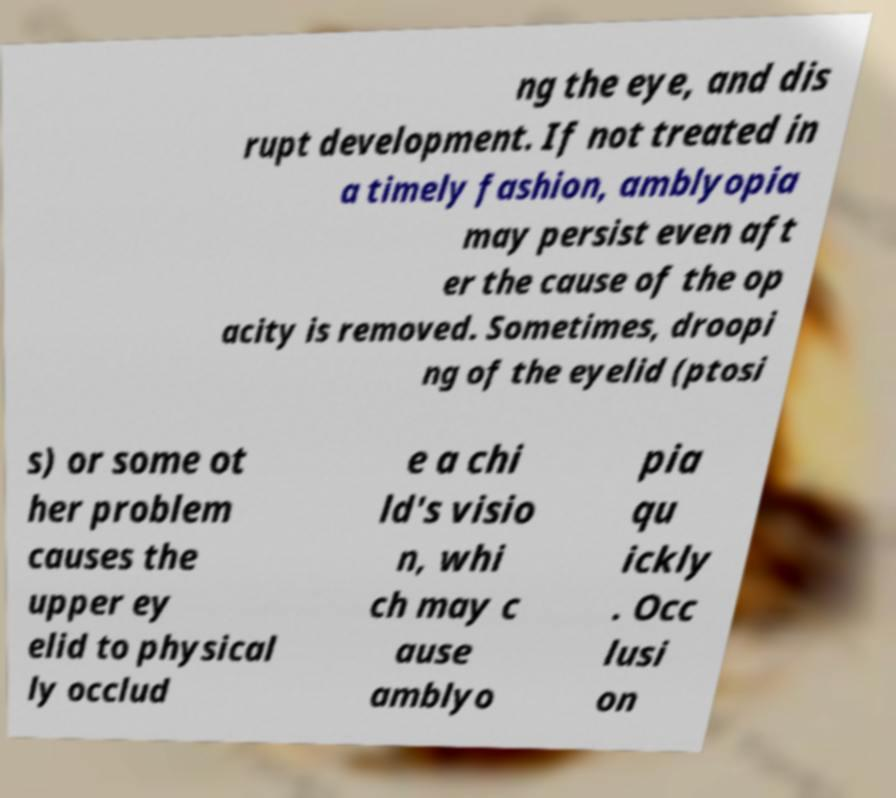What messages or text are displayed in this image? I need them in a readable, typed format. ng the eye, and dis rupt development. If not treated in a timely fashion, amblyopia may persist even aft er the cause of the op acity is removed. Sometimes, droopi ng of the eyelid (ptosi s) or some ot her problem causes the upper ey elid to physical ly occlud e a chi ld's visio n, whi ch may c ause amblyo pia qu ickly . Occ lusi on 